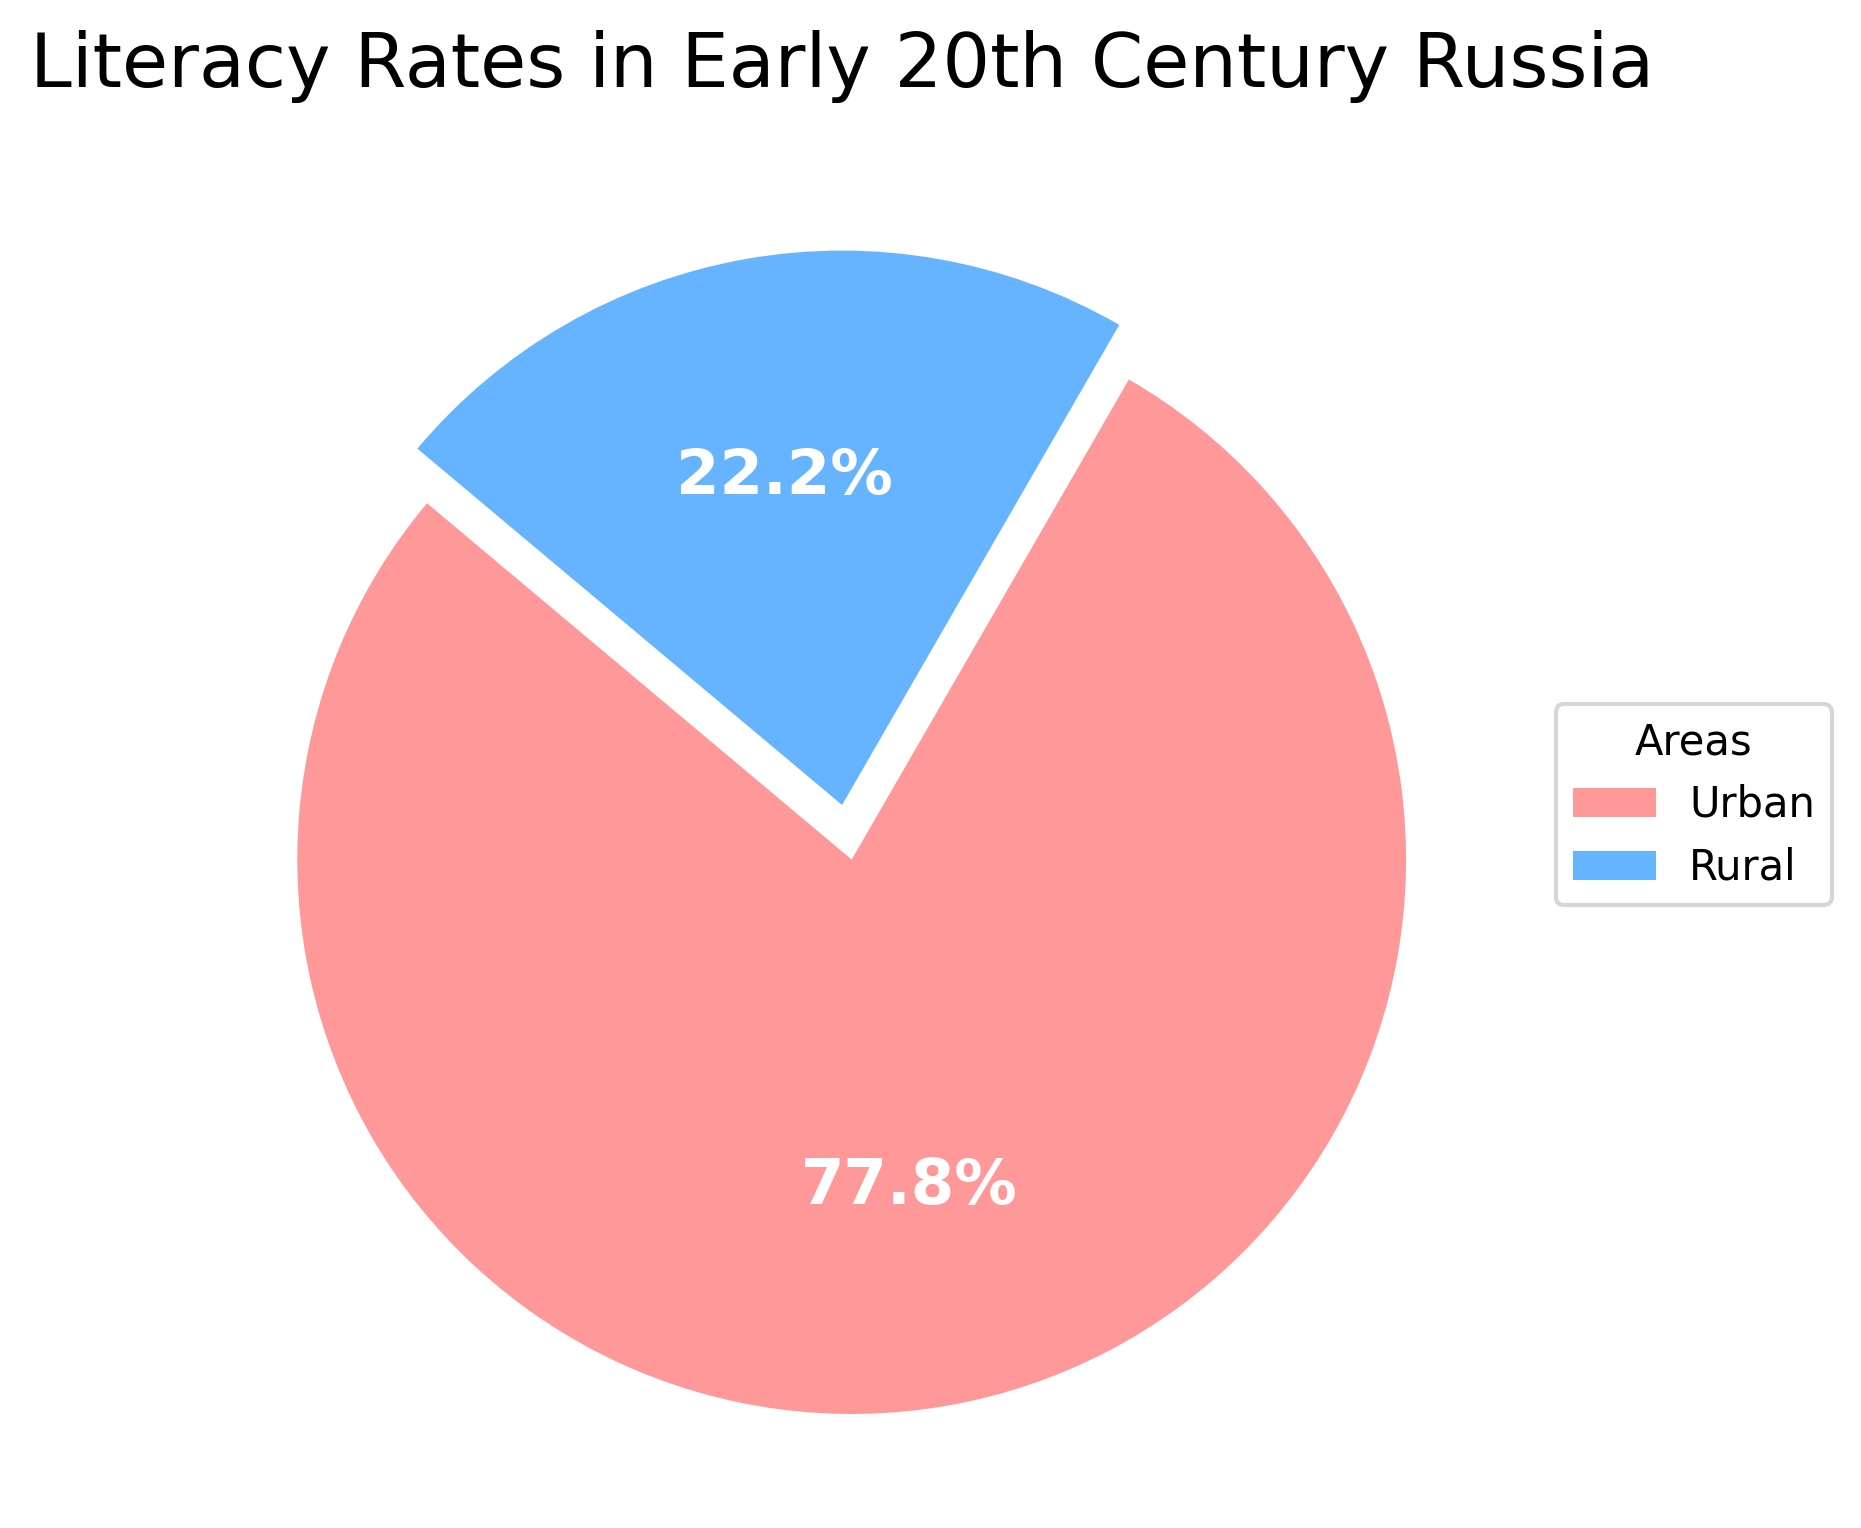What's the literacy rate in urban areas? Based on the pie chart, urban areas have a literacy rate of 70%. This is shown directly in the chart label for the urban segment.
Answer: 70% What's the literacy rate in rural areas? The pie chart indicates that rural areas have a literacy rate of 20%. This is shown directly in the chart label for the rural segment.
Answer: 20% Which area has a higher literacy rate, urban or rural? By examining the labels on the pie chart, the urban area shows a literacy rate of 70%, which is higher than the rural area's literacy rate of 20%.
Answer: Urban By how much does the literacy rate in urban areas exceed that in rural areas? Subtract the rural literacy rate (20%) from the urban literacy rate (70%). The result is 70% - 20% = 50%.
Answer: 50% What percentage of the total literacy rate does the rural area represent? The rural literacy rate is 20%, and the total is 100%. So, the rural literacy rate represents 20% of the total literacy rate.
Answer: 20% What percentage of the total literacy rate does the urban area represent? The urban literacy rate is 70%, and the total is 100%. So, the urban literacy rate represents 70% of the total literacy rate.
Answer: 70% How much larger is the urban literacy rate compared to the rural literacy rate, percentage-wise? To find how much larger the urban rate is compared to the rural rate percentage-wise, use the formula (urban - rural) / rural * 100. It calculates as (70% - 20%) / 20% * 100 = 250%.
Answer: 250% Which segment of the pie chart is larger, the urban segment or the rural segment? Visually, the pie chart segment for urban areas is larger. This is because it represents a 70% literacy rate, whereas the rural segment represents a 20% literacy rate.
Answer: Urban What does the color red represent in the pie chart? In the pie chart, the color red represents the literacy rate for urban areas. This can be identified by consulting the legend within the chart.
Answer: Urban What does the color blue represent in the pie chart? In the pie chart, the color blue represents the literacy rate for rural areas. This can be identified by consulting the legend within the chart.
Answer: Rural 